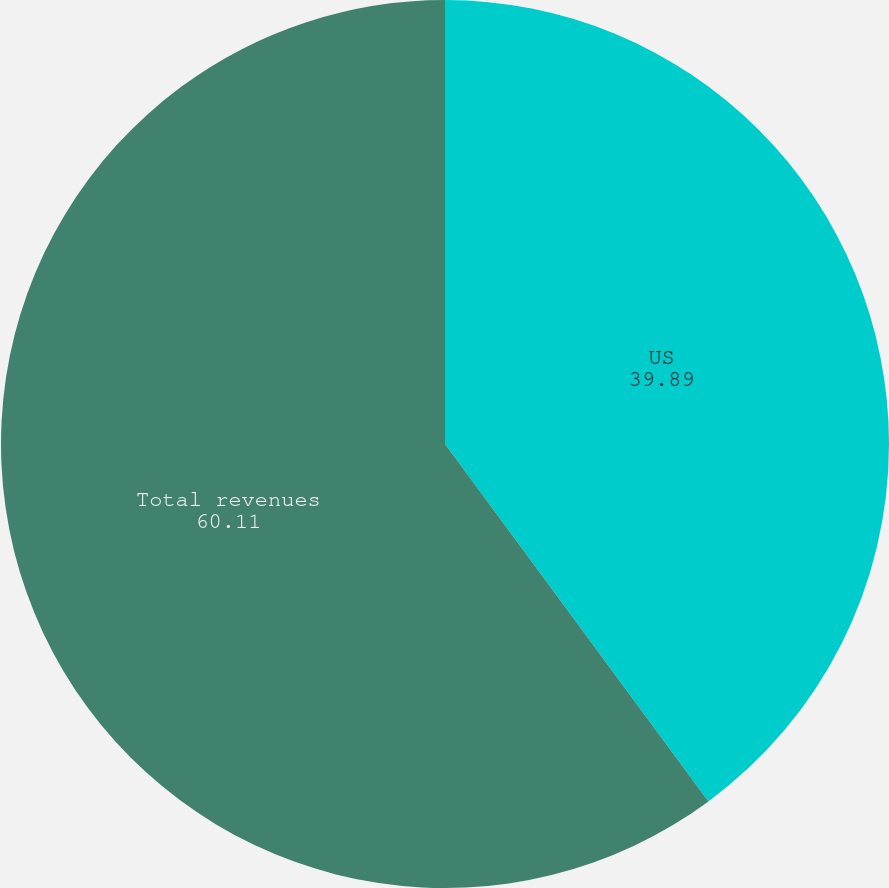Convert chart. <chart><loc_0><loc_0><loc_500><loc_500><pie_chart><fcel>US<fcel>Total revenues<nl><fcel>39.89%<fcel>60.11%<nl></chart> 